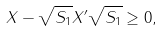Convert formula to latex. <formula><loc_0><loc_0><loc_500><loc_500>X - \sqrt { S _ { 1 } } X ^ { \prime } \sqrt { S _ { 1 } } \geq 0 ,</formula> 